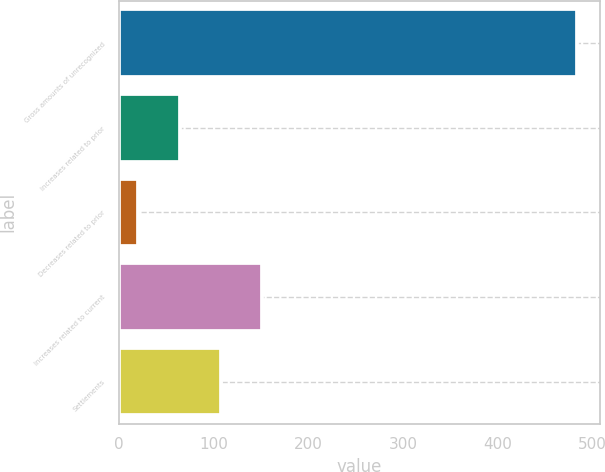<chart> <loc_0><loc_0><loc_500><loc_500><bar_chart><fcel>Gross amounts of unrecognized<fcel>Increases related to prior<fcel>Decreases related to prior<fcel>Increases related to current<fcel>Settlements<nl><fcel>483.8<fcel>63.8<fcel>20<fcel>151.4<fcel>107.6<nl></chart> 